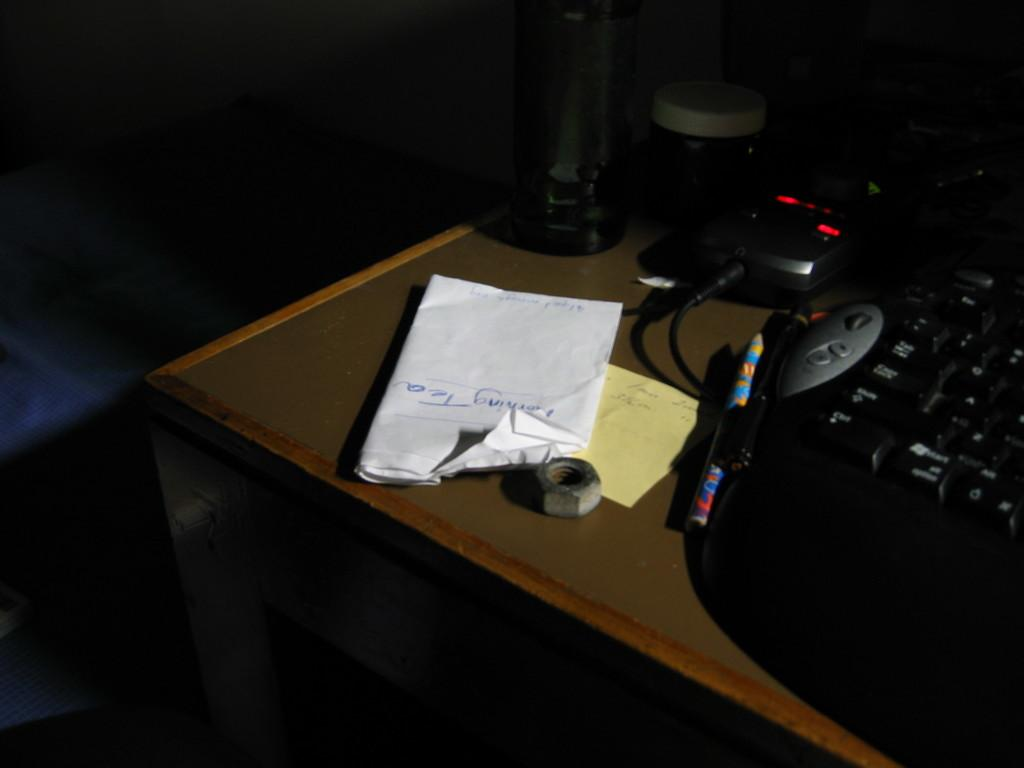Provide a one-sentence caption for the provided image. A white piece of paper with "morning tea" sits on a table. 